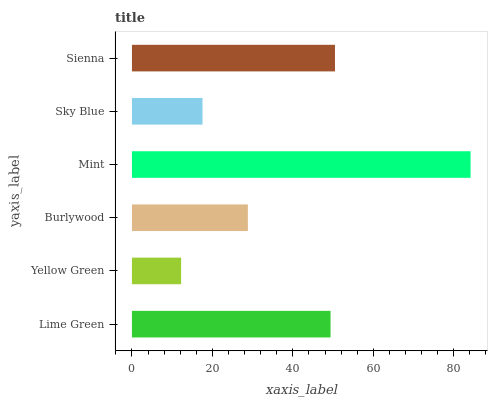Is Yellow Green the minimum?
Answer yes or no. Yes. Is Mint the maximum?
Answer yes or no. Yes. Is Burlywood the minimum?
Answer yes or no. No. Is Burlywood the maximum?
Answer yes or no. No. Is Burlywood greater than Yellow Green?
Answer yes or no. Yes. Is Yellow Green less than Burlywood?
Answer yes or no. Yes. Is Yellow Green greater than Burlywood?
Answer yes or no. No. Is Burlywood less than Yellow Green?
Answer yes or no. No. Is Lime Green the high median?
Answer yes or no. Yes. Is Burlywood the low median?
Answer yes or no. Yes. Is Sky Blue the high median?
Answer yes or no. No. Is Mint the low median?
Answer yes or no. No. 